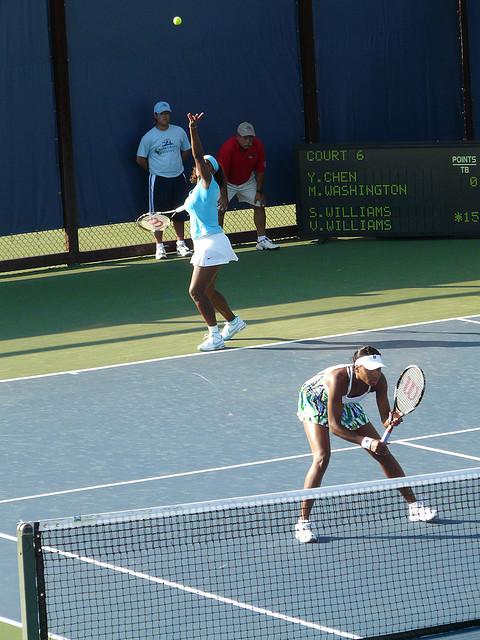Who is winning this game?
Answer briefly. Williams. Is this a singles or doubles game?
Concise answer only. Doubles. Is the lady bent forward or backwards?
Keep it brief. Forward. What sport is this?
Concise answer only. Tennis. 